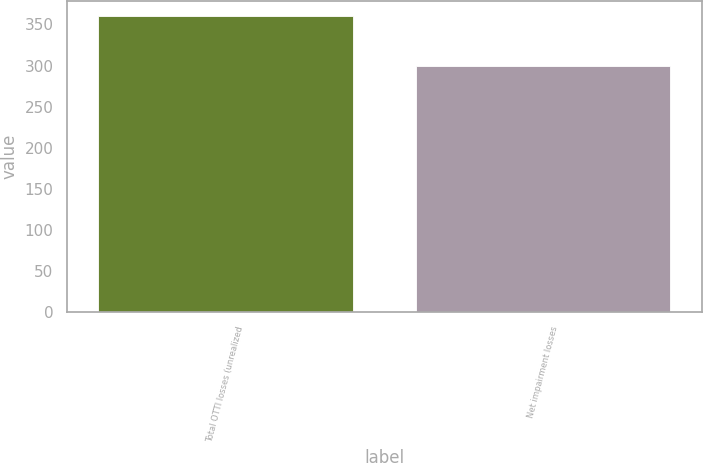Convert chart. <chart><loc_0><loc_0><loc_500><loc_500><bar_chart><fcel>Total OTTI losses (unrealized<fcel>Net impairment losses<nl><fcel>360<fcel>299<nl></chart> 